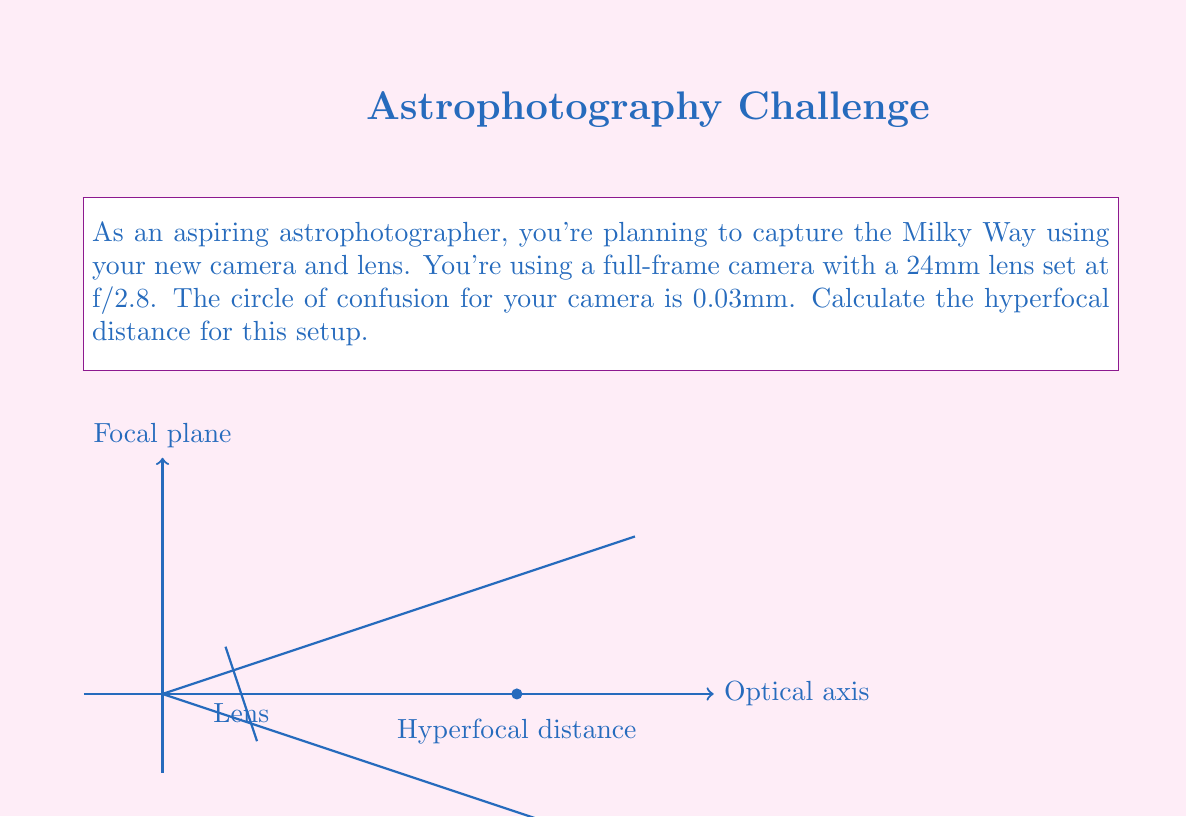Help me with this question. To calculate the hyperfocal distance, we'll use the following formula:

$$ H = \frac{f^2}{N \cdot c} + f $$

Where:
$H$ = Hyperfocal distance
$f$ = Focal length
$N$ = f-number (aperture)
$c$ = Circle of confusion

Let's plug in our values:

$f = 24$ mm
$N = 2.8$
$c = 0.03$ mm

Now, let's solve step by step:

1) First, calculate $f^2$:
   $f^2 = 24^2 = 576$ mm²

2) Multiply $N$ and $c$:
   $N \cdot c = 2.8 \cdot 0.03 = 0.084$ mm

3) Divide $f^2$ by $(N \cdot c)$:
   $\frac{f^2}{N \cdot c} = \frac{576}{0.084} \approx 6857.14$ mm

4) Add the focal length $f$:
   $6857.14 + 24 \approx 6881.14$ mm

5) Convert to meters:
   $6881.14$ mm $\approx 6.88$ m

Therefore, the hyperfocal distance for this setup is approximately 6.88 meters.
Answer: $6.88$ m 